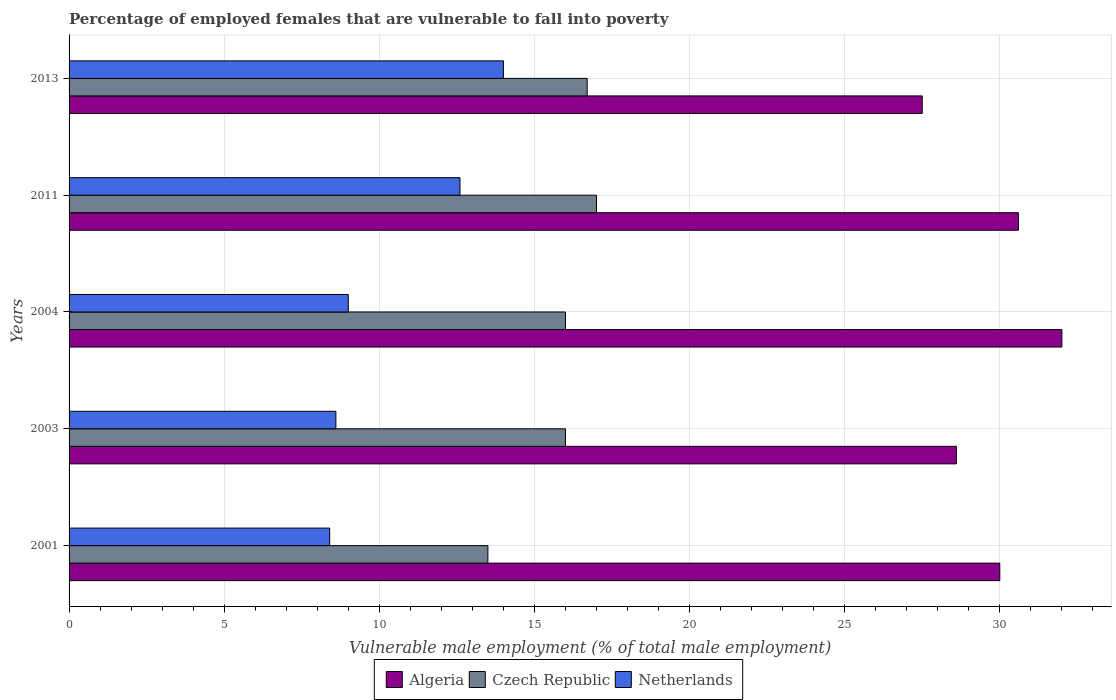How many groups of bars are there?
Your answer should be compact. 5. Are the number of bars on each tick of the Y-axis equal?
Provide a succinct answer. Yes. How many bars are there on the 1st tick from the bottom?
Provide a succinct answer. 3. In how many cases, is the number of bars for a given year not equal to the number of legend labels?
Provide a short and direct response. 0. Across all years, what is the maximum percentage of employed females who are vulnerable to fall into poverty in Algeria?
Your response must be concise. 32. What is the total percentage of employed females who are vulnerable to fall into poverty in Czech Republic in the graph?
Keep it short and to the point. 79.2. What is the difference between the percentage of employed females who are vulnerable to fall into poverty in Netherlands in 2003 and that in 2011?
Offer a very short reply. -4. What is the difference between the percentage of employed females who are vulnerable to fall into poverty in Algeria in 2013 and the percentage of employed females who are vulnerable to fall into poverty in Netherlands in 2003?
Ensure brevity in your answer.  18.9. What is the average percentage of employed females who are vulnerable to fall into poverty in Czech Republic per year?
Offer a terse response. 15.84. In the year 2003, what is the difference between the percentage of employed females who are vulnerable to fall into poverty in Czech Republic and percentage of employed females who are vulnerable to fall into poverty in Netherlands?
Give a very brief answer. 7.4. In how many years, is the percentage of employed females who are vulnerable to fall into poverty in Czech Republic greater than 3 %?
Ensure brevity in your answer.  5. What is the ratio of the percentage of employed females who are vulnerable to fall into poverty in Algeria in 2003 to that in 2013?
Your answer should be compact. 1.04. What is the difference between the highest and the second highest percentage of employed females who are vulnerable to fall into poverty in Czech Republic?
Keep it short and to the point. 0.3. What does the 2nd bar from the top in 2011 represents?
Give a very brief answer. Czech Republic. What does the 1st bar from the bottom in 2003 represents?
Your response must be concise. Algeria. How many years are there in the graph?
Provide a succinct answer. 5. Are the values on the major ticks of X-axis written in scientific E-notation?
Offer a very short reply. No. Does the graph contain any zero values?
Make the answer very short. No. Does the graph contain grids?
Provide a succinct answer. Yes. Where does the legend appear in the graph?
Keep it short and to the point. Bottom center. How many legend labels are there?
Your answer should be compact. 3. How are the legend labels stacked?
Your answer should be compact. Horizontal. What is the title of the graph?
Your answer should be compact. Percentage of employed females that are vulnerable to fall into poverty. What is the label or title of the X-axis?
Give a very brief answer. Vulnerable male employment (% of total male employment). What is the Vulnerable male employment (% of total male employment) of Czech Republic in 2001?
Offer a very short reply. 13.5. What is the Vulnerable male employment (% of total male employment) in Netherlands in 2001?
Your answer should be very brief. 8.4. What is the Vulnerable male employment (% of total male employment) of Algeria in 2003?
Keep it short and to the point. 28.6. What is the Vulnerable male employment (% of total male employment) in Netherlands in 2003?
Offer a very short reply. 8.6. What is the Vulnerable male employment (% of total male employment) of Algeria in 2011?
Give a very brief answer. 30.6. What is the Vulnerable male employment (% of total male employment) of Netherlands in 2011?
Ensure brevity in your answer.  12.6. What is the Vulnerable male employment (% of total male employment) in Czech Republic in 2013?
Your answer should be compact. 16.7. Across all years, what is the maximum Vulnerable male employment (% of total male employment) of Algeria?
Provide a succinct answer. 32. Across all years, what is the minimum Vulnerable male employment (% of total male employment) of Algeria?
Make the answer very short. 27.5. Across all years, what is the minimum Vulnerable male employment (% of total male employment) of Czech Republic?
Your response must be concise. 13.5. Across all years, what is the minimum Vulnerable male employment (% of total male employment) in Netherlands?
Ensure brevity in your answer.  8.4. What is the total Vulnerable male employment (% of total male employment) of Algeria in the graph?
Your response must be concise. 148.7. What is the total Vulnerable male employment (% of total male employment) of Czech Republic in the graph?
Make the answer very short. 79.2. What is the total Vulnerable male employment (% of total male employment) in Netherlands in the graph?
Keep it short and to the point. 52.6. What is the difference between the Vulnerable male employment (% of total male employment) in Algeria in 2001 and that in 2004?
Make the answer very short. -2. What is the difference between the Vulnerable male employment (% of total male employment) of Algeria in 2001 and that in 2011?
Provide a succinct answer. -0.6. What is the difference between the Vulnerable male employment (% of total male employment) in Netherlands in 2001 and that in 2011?
Keep it short and to the point. -4.2. What is the difference between the Vulnerable male employment (% of total male employment) in Netherlands in 2001 and that in 2013?
Your response must be concise. -5.6. What is the difference between the Vulnerable male employment (% of total male employment) of Algeria in 2003 and that in 2004?
Make the answer very short. -3.4. What is the difference between the Vulnerable male employment (% of total male employment) in Czech Republic in 2003 and that in 2004?
Make the answer very short. 0. What is the difference between the Vulnerable male employment (% of total male employment) of Netherlands in 2003 and that in 2011?
Ensure brevity in your answer.  -4. What is the difference between the Vulnerable male employment (% of total male employment) of Czech Republic in 2003 and that in 2013?
Offer a terse response. -0.7. What is the difference between the Vulnerable male employment (% of total male employment) of Czech Republic in 2004 and that in 2013?
Ensure brevity in your answer.  -0.7. What is the difference between the Vulnerable male employment (% of total male employment) in Czech Republic in 2011 and that in 2013?
Offer a terse response. 0.3. What is the difference between the Vulnerable male employment (% of total male employment) of Algeria in 2001 and the Vulnerable male employment (% of total male employment) of Netherlands in 2003?
Offer a very short reply. 21.4. What is the difference between the Vulnerable male employment (% of total male employment) in Czech Republic in 2001 and the Vulnerable male employment (% of total male employment) in Netherlands in 2003?
Keep it short and to the point. 4.9. What is the difference between the Vulnerable male employment (% of total male employment) in Algeria in 2001 and the Vulnerable male employment (% of total male employment) in Netherlands in 2004?
Make the answer very short. 21. What is the difference between the Vulnerable male employment (% of total male employment) in Czech Republic in 2001 and the Vulnerable male employment (% of total male employment) in Netherlands in 2004?
Your response must be concise. 4.5. What is the difference between the Vulnerable male employment (% of total male employment) of Algeria in 2001 and the Vulnerable male employment (% of total male employment) of Czech Republic in 2013?
Give a very brief answer. 13.3. What is the difference between the Vulnerable male employment (% of total male employment) of Algeria in 2001 and the Vulnerable male employment (% of total male employment) of Netherlands in 2013?
Your answer should be very brief. 16. What is the difference between the Vulnerable male employment (% of total male employment) in Czech Republic in 2001 and the Vulnerable male employment (% of total male employment) in Netherlands in 2013?
Give a very brief answer. -0.5. What is the difference between the Vulnerable male employment (% of total male employment) of Algeria in 2003 and the Vulnerable male employment (% of total male employment) of Netherlands in 2004?
Your answer should be compact. 19.6. What is the difference between the Vulnerable male employment (% of total male employment) of Algeria in 2003 and the Vulnerable male employment (% of total male employment) of Czech Republic in 2011?
Give a very brief answer. 11.6. What is the difference between the Vulnerable male employment (% of total male employment) of Czech Republic in 2003 and the Vulnerable male employment (% of total male employment) of Netherlands in 2011?
Give a very brief answer. 3.4. What is the difference between the Vulnerable male employment (% of total male employment) in Czech Republic in 2003 and the Vulnerable male employment (% of total male employment) in Netherlands in 2013?
Make the answer very short. 2. What is the difference between the Vulnerable male employment (% of total male employment) of Algeria in 2004 and the Vulnerable male employment (% of total male employment) of Czech Republic in 2011?
Ensure brevity in your answer.  15. What is the difference between the Vulnerable male employment (% of total male employment) of Czech Republic in 2004 and the Vulnerable male employment (% of total male employment) of Netherlands in 2013?
Your answer should be very brief. 2. What is the difference between the Vulnerable male employment (% of total male employment) of Algeria in 2011 and the Vulnerable male employment (% of total male employment) of Czech Republic in 2013?
Give a very brief answer. 13.9. What is the difference between the Vulnerable male employment (% of total male employment) in Czech Republic in 2011 and the Vulnerable male employment (% of total male employment) in Netherlands in 2013?
Provide a succinct answer. 3. What is the average Vulnerable male employment (% of total male employment) of Algeria per year?
Keep it short and to the point. 29.74. What is the average Vulnerable male employment (% of total male employment) of Czech Republic per year?
Offer a very short reply. 15.84. What is the average Vulnerable male employment (% of total male employment) in Netherlands per year?
Offer a very short reply. 10.52. In the year 2001, what is the difference between the Vulnerable male employment (% of total male employment) in Algeria and Vulnerable male employment (% of total male employment) in Netherlands?
Keep it short and to the point. 21.6. In the year 2003, what is the difference between the Vulnerable male employment (% of total male employment) in Algeria and Vulnerable male employment (% of total male employment) in Czech Republic?
Provide a short and direct response. 12.6. In the year 2011, what is the difference between the Vulnerable male employment (% of total male employment) in Czech Republic and Vulnerable male employment (% of total male employment) in Netherlands?
Make the answer very short. 4.4. In the year 2013, what is the difference between the Vulnerable male employment (% of total male employment) of Algeria and Vulnerable male employment (% of total male employment) of Netherlands?
Make the answer very short. 13.5. In the year 2013, what is the difference between the Vulnerable male employment (% of total male employment) of Czech Republic and Vulnerable male employment (% of total male employment) of Netherlands?
Offer a terse response. 2.7. What is the ratio of the Vulnerable male employment (% of total male employment) in Algeria in 2001 to that in 2003?
Provide a succinct answer. 1.05. What is the ratio of the Vulnerable male employment (% of total male employment) in Czech Republic in 2001 to that in 2003?
Your answer should be very brief. 0.84. What is the ratio of the Vulnerable male employment (% of total male employment) in Netherlands in 2001 to that in 2003?
Your answer should be very brief. 0.98. What is the ratio of the Vulnerable male employment (% of total male employment) in Czech Republic in 2001 to that in 2004?
Your response must be concise. 0.84. What is the ratio of the Vulnerable male employment (% of total male employment) of Algeria in 2001 to that in 2011?
Offer a terse response. 0.98. What is the ratio of the Vulnerable male employment (% of total male employment) in Czech Republic in 2001 to that in 2011?
Provide a short and direct response. 0.79. What is the ratio of the Vulnerable male employment (% of total male employment) in Czech Republic in 2001 to that in 2013?
Provide a succinct answer. 0.81. What is the ratio of the Vulnerable male employment (% of total male employment) of Netherlands in 2001 to that in 2013?
Make the answer very short. 0.6. What is the ratio of the Vulnerable male employment (% of total male employment) in Algeria in 2003 to that in 2004?
Your answer should be very brief. 0.89. What is the ratio of the Vulnerable male employment (% of total male employment) in Netherlands in 2003 to that in 2004?
Offer a terse response. 0.96. What is the ratio of the Vulnerable male employment (% of total male employment) in Algeria in 2003 to that in 2011?
Offer a very short reply. 0.93. What is the ratio of the Vulnerable male employment (% of total male employment) in Netherlands in 2003 to that in 2011?
Your answer should be compact. 0.68. What is the ratio of the Vulnerable male employment (% of total male employment) of Algeria in 2003 to that in 2013?
Keep it short and to the point. 1.04. What is the ratio of the Vulnerable male employment (% of total male employment) of Czech Republic in 2003 to that in 2013?
Give a very brief answer. 0.96. What is the ratio of the Vulnerable male employment (% of total male employment) in Netherlands in 2003 to that in 2013?
Your answer should be very brief. 0.61. What is the ratio of the Vulnerable male employment (% of total male employment) in Algeria in 2004 to that in 2011?
Give a very brief answer. 1.05. What is the ratio of the Vulnerable male employment (% of total male employment) of Netherlands in 2004 to that in 2011?
Provide a succinct answer. 0.71. What is the ratio of the Vulnerable male employment (% of total male employment) in Algeria in 2004 to that in 2013?
Provide a short and direct response. 1.16. What is the ratio of the Vulnerable male employment (% of total male employment) in Czech Republic in 2004 to that in 2013?
Offer a very short reply. 0.96. What is the ratio of the Vulnerable male employment (% of total male employment) in Netherlands in 2004 to that in 2013?
Your answer should be compact. 0.64. What is the ratio of the Vulnerable male employment (% of total male employment) of Algeria in 2011 to that in 2013?
Provide a succinct answer. 1.11. What is the difference between the highest and the lowest Vulnerable male employment (% of total male employment) in Czech Republic?
Offer a terse response. 3.5. 